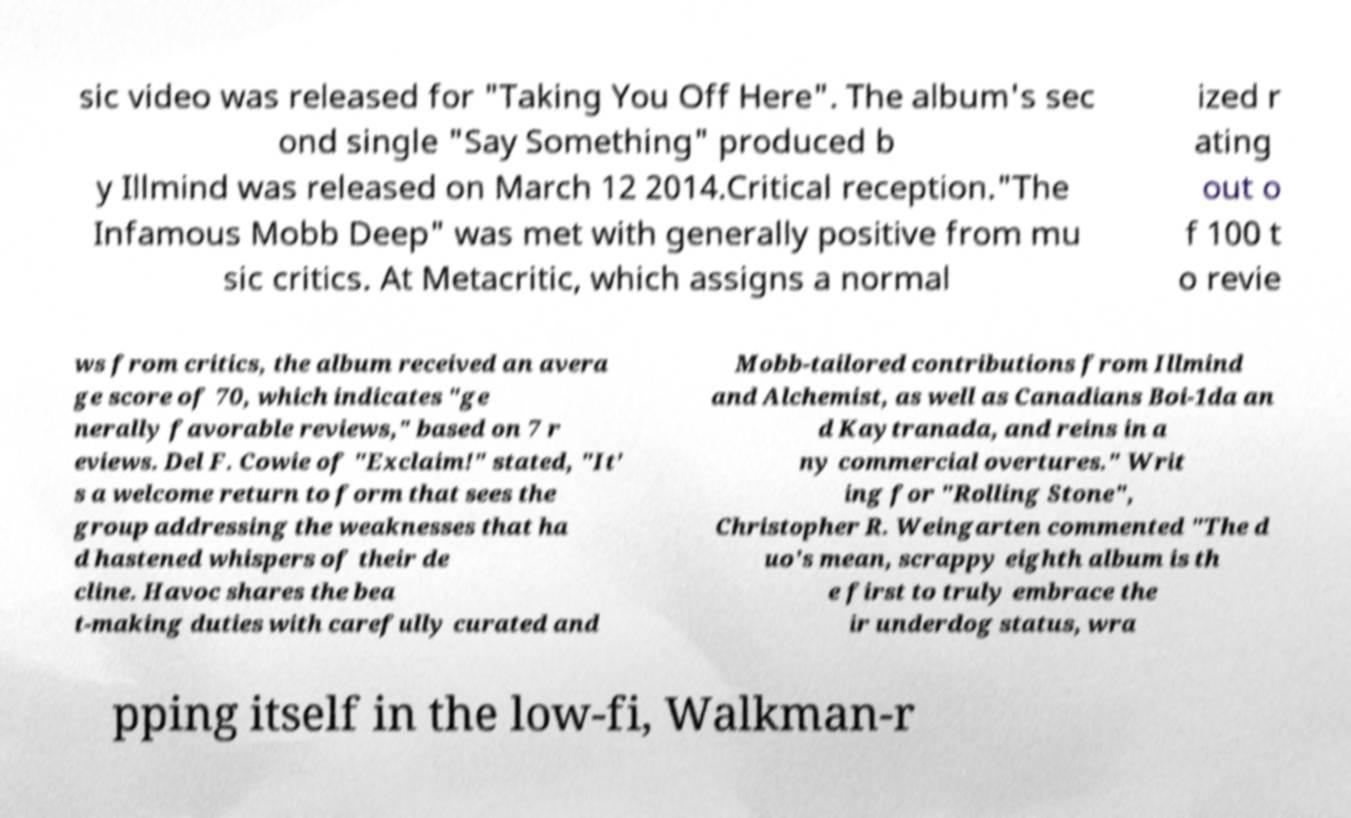Please read and relay the text visible in this image. What does it say? sic video was released for "Taking You Off Here". The album's sec ond single "Say Something" produced b y Illmind was released on March 12 2014.Critical reception."The Infamous Mobb Deep" was met with generally positive from mu sic critics. At Metacritic, which assigns a normal ized r ating out o f 100 t o revie ws from critics, the album received an avera ge score of 70, which indicates "ge nerally favorable reviews," based on 7 r eviews. Del F. Cowie of "Exclaim!" stated, "It' s a welcome return to form that sees the group addressing the weaknesses that ha d hastened whispers of their de cline. Havoc shares the bea t-making duties with carefully curated and Mobb-tailored contributions from Illmind and Alchemist, as well as Canadians Boi-1da an d Kaytranada, and reins in a ny commercial overtures." Writ ing for "Rolling Stone", Christopher R. Weingarten commented "The d uo's mean, scrappy eighth album is th e first to truly embrace the ir underdog status, wra pping itself in the low-fi, Walkman-r 